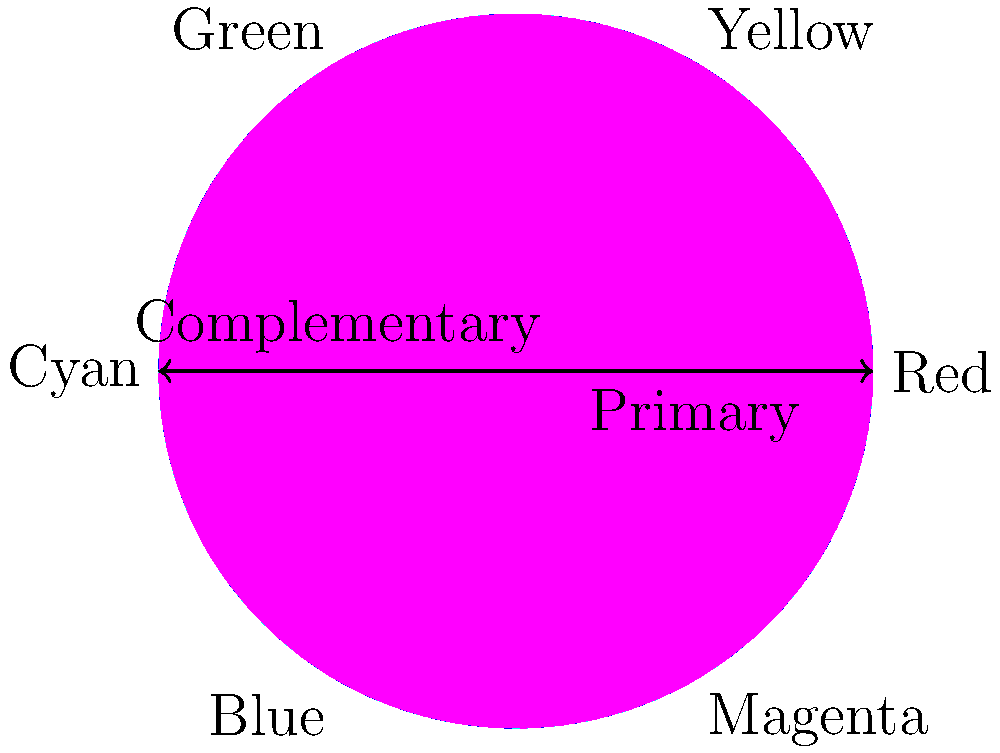As an animator and webcomic creator, understanding color theory is crucial for creating visually appealing content. Based on the color wheel diagram, which color is complementary to yellow, and how might this knowledge be applied in your webcomic to create visual contrast or tension? 1. Analyze the color wheel:
   - The color wheel is divided into six main colors: Red, Yellow, Green, Cyan, Blue, and Magenta.
   - These colors are arranged in a specific order, following the visible light spectrum.

2. Identify complementary colors:
   - Complementary colors are located directly opposite each other on the color wheel.
   - They create maximum contrast when used together.

3. Find yellow's position:
   - Yellow is located at the top right of the wheel, at approximately 60 degrees.

4. Locate the complementary color:
   - The color directly opposite yellow (180 degrees away) is blue.

5. Application in webcomics:
   - Using yellow and blue together can create strong visual contrast.
   - This contrast can be used to:
     a. Draw attention to important elements in a panel.
     b. Create visual tension between characters or objects.
     c. Separate foreground and background elements.
     d. Evoke specific moods or emotions (e.g., warm vs. cool).

6. Examples in animation and webcomics:
   - Character design: A character with yellow clothing against a blue background will stand out.
   - Environmental contrast: A yellow sun in a blue sky creates a vibrant, eye-catching scene.
   - Emotional storytelling: Using warm yellows and cool blues to represent different emotional states or character perspectives.
Answer: Blue; create visual contrast, highlight important elements, and evoke specific moods. 